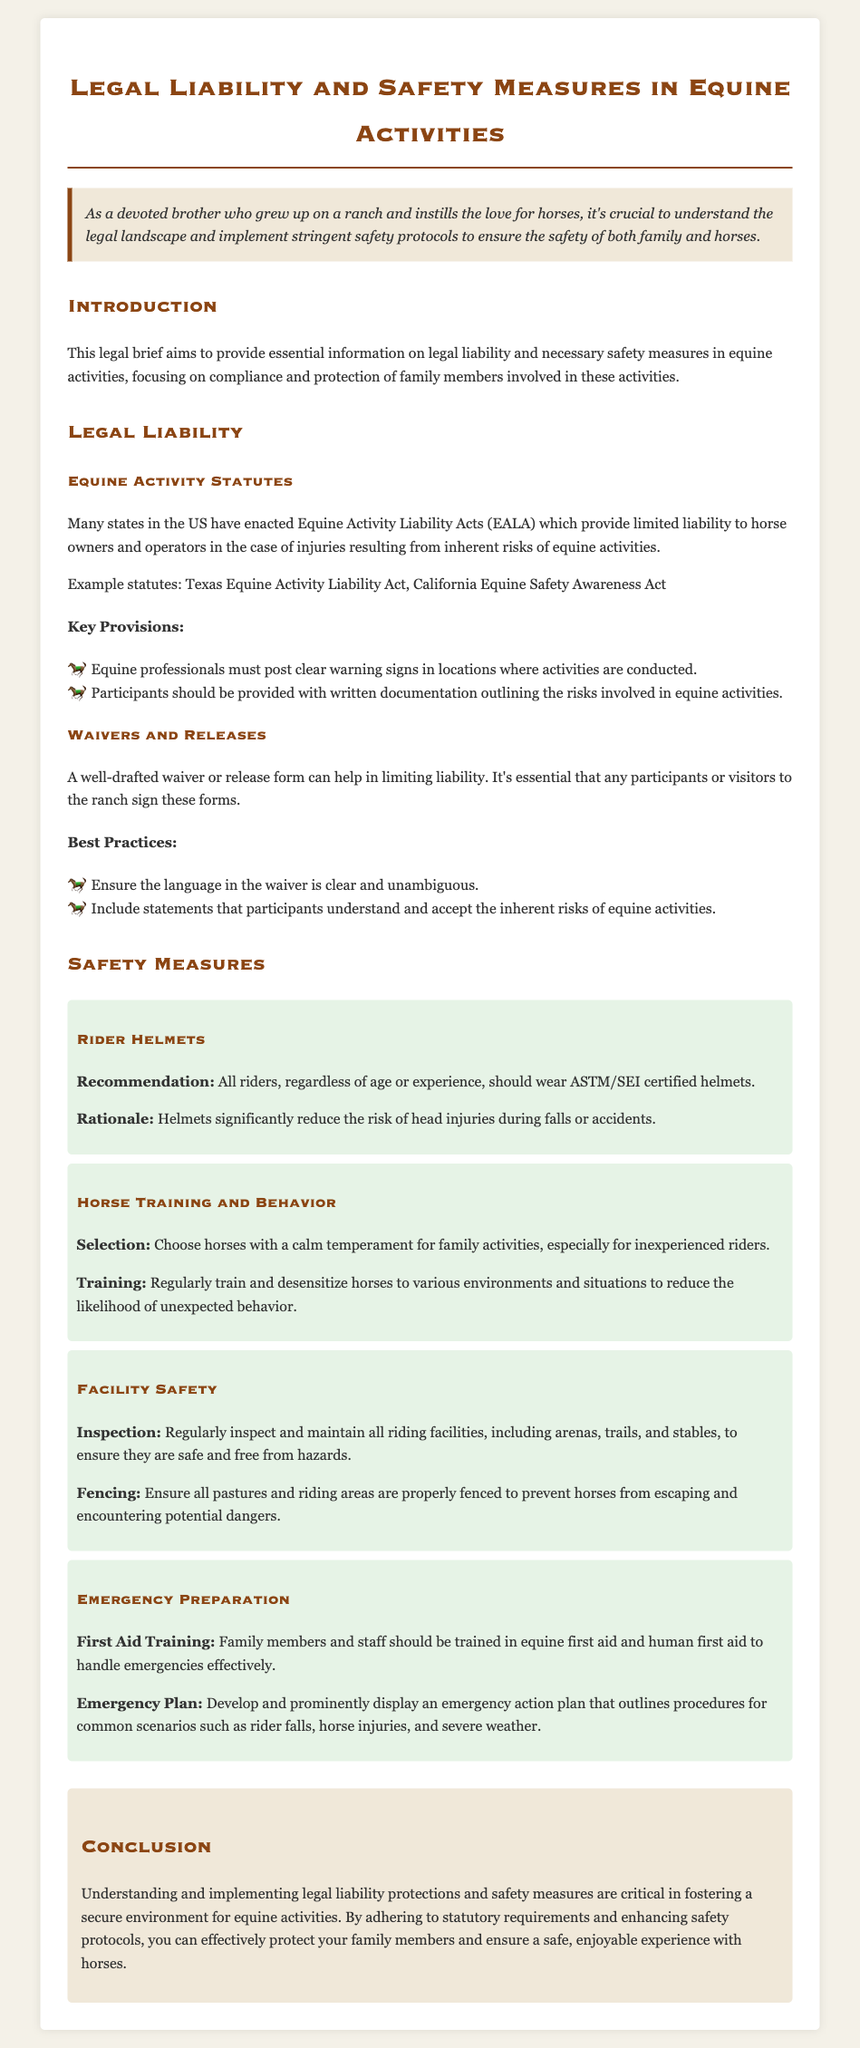What is the main purpose of the legal brief? The brief aims to provide essential information on legal liability and necessary safety measures in equine activities.
Answer: To provide essential information on legal liability and necessary safety measures What is the example statute mentioned? The document mentions the Texas Equine Activity Liability Act as an example statute.
Answer: Texas Equine Activity Liability Act What should participants receive according to key provisions? Participants should be provided with written documentation outlining the risks involved in equine activities.
Answer: Written documentation outlining the risks What is recommended for all riders? The recommendation is that all riders should wear ASTM/SEI certified helmets.
Answer: ASTM/SEI certified helmets What type of training should family members and staff have? Family members and staff should be trained in equine first aid and human first aid.
Answer: Equine first aid and human first aid What does the emergency plan outline? The emergency plan outlines procedures for common scenarios such as rider falls and horse injuries.
Answer: Procedures for common scenarios such as rider falls and horse injuries What is one key safety measure for facility maintenance? Regularly inspect and maintain all riding facilities to ensure they are safe and free from hazards.
Answer: Regularly inspect and maintain all riding facilities What does a well-drafted waiver do? A well-drafted waiver helps in limiting liability for participants and visitors.
Answer: Helps in limiting liability 